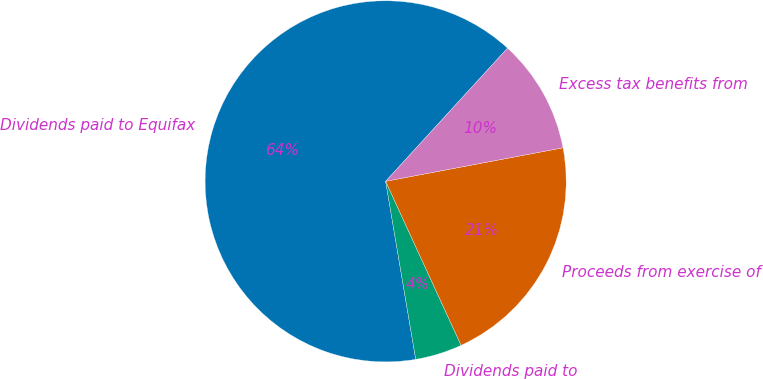Convert chart. <chart><loc_0><loc_0><loc_500><loc_500><pie_chart><fcel>Dividends paid to Equifax<fcel>Dividends paid to<fcel>Proceeds from exercise of<fcel>Excess tax benefits from<nl><fcel>64.46%<fcel>4.2%<fcel>21.11%<fcel>10.23%<nl></chart> 